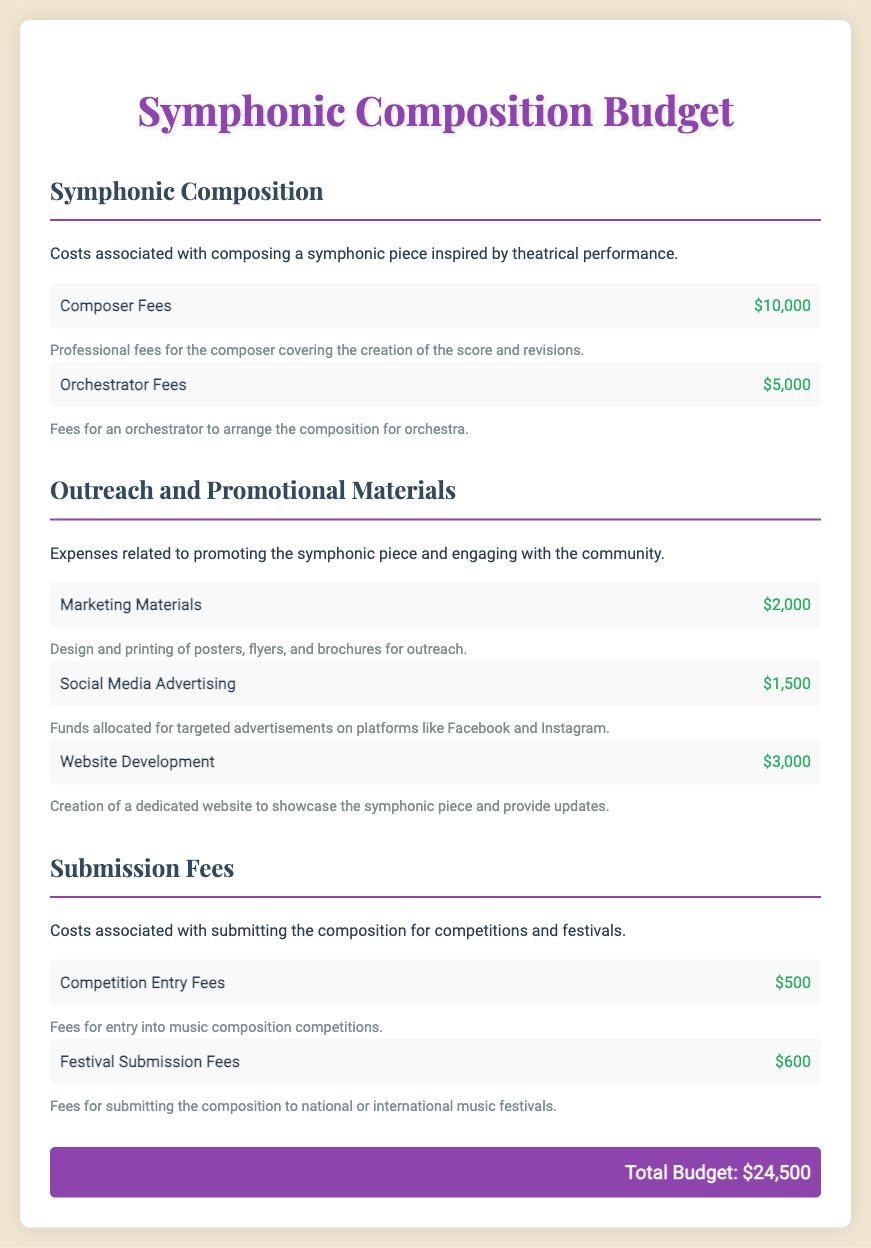What is the total budget? The total budget is stated at the end of the document, summing all costs listed across different sections.
Answer: $24,500 How much is allocated for composer fees? Composer fees are detailed in the first budget section, indicating the cost for professional composition work.
Answer: $10,000 What is the cost for marketing materials? Marketing materials are listed under outreach expenses, showing the cost for designing and printing promotional items.
Answer: $2,000 How much will be spent on competition entry fees? Competition entry fees are mentioned in the submission fees section, providing the cost for entering competitions.
Answer: $500 What is the amount for social media advertising? The document specifies the allocated funds for targeted advertisements in the outreach and promotional materials section.
Answer: $1,500 Which section details the expenses for orchestrator fees? Orchestrator fees are found in the first section titled “Symphonic Composition,” outlining costs specific to orchestration.
Answer: Symphonic Composition What is the fee for festival submission? The fee for festival submission is detailed along with competition entry fees in the submission fees section of the budget.
Answer: $600 How much is budgeted for website development? Website development costs are specified in the outreach and promotional materials section, indicating its importance for online presence.
Answer: $3,000 What are the two types of fees included in the submission fees section? The submission fees section lists both competition entry fees and festival submission fees as the types of expenses.
Answer: Competition Entry Fees, Festival Submission Fees 